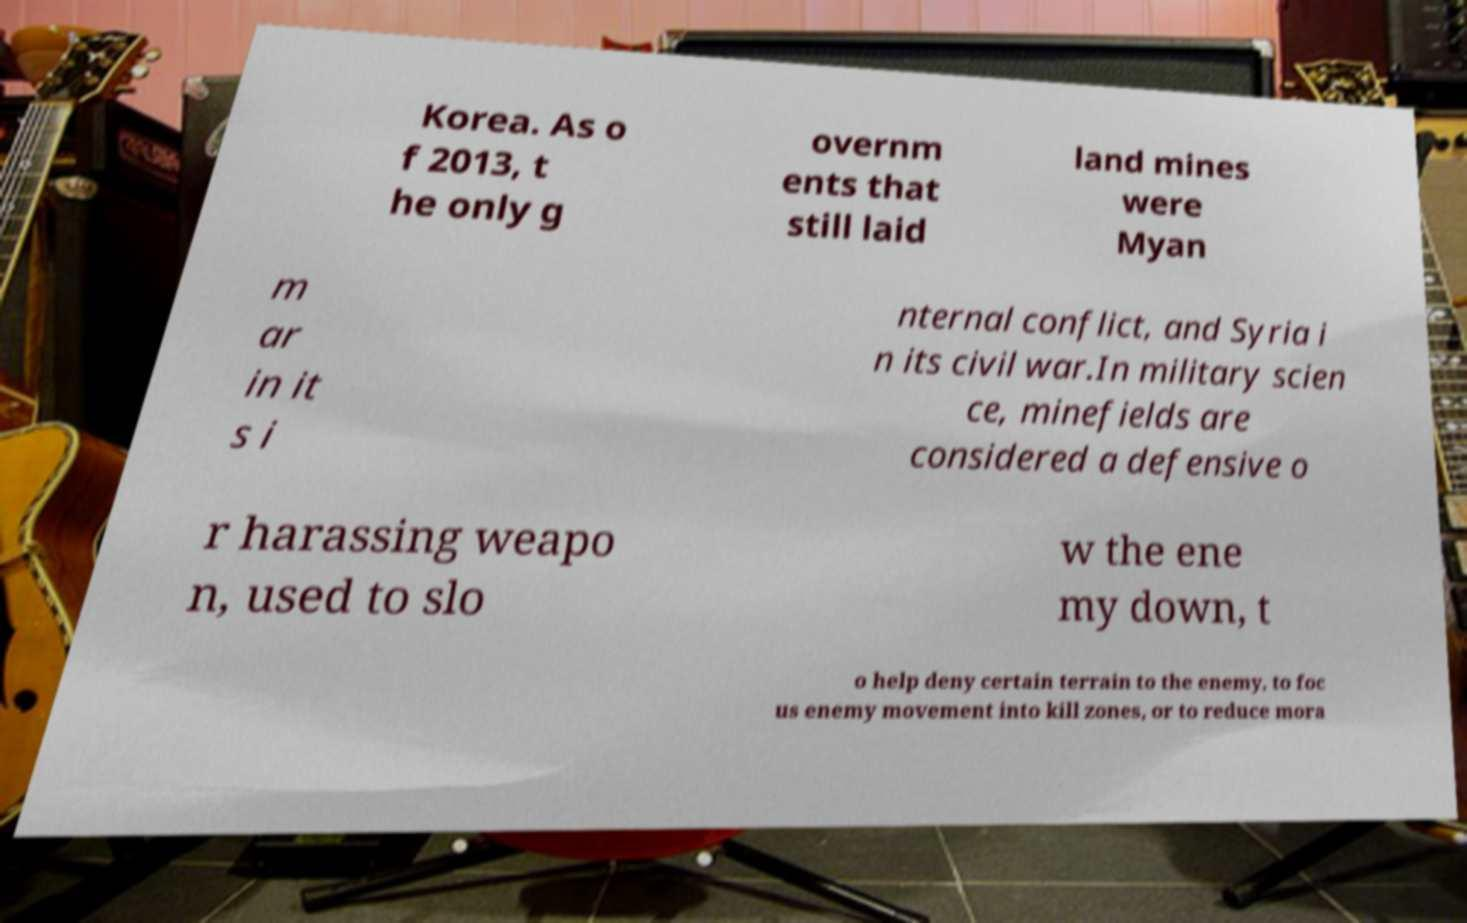Could you assist in decoding the text presented in this image and type it out clearly? Korea. As o f 2013, t he only g overnm ents that still laid land mines were Myan m ar in it s i nternal conflict, and Syria i n its civil war.In military scien ce, minefields are considered a defensive o r harassing weapo n, used to slo w the ene my down, t o help deny certain terrain to the enemy, to foc us enemy movement into kill zones, or to reduce mora 